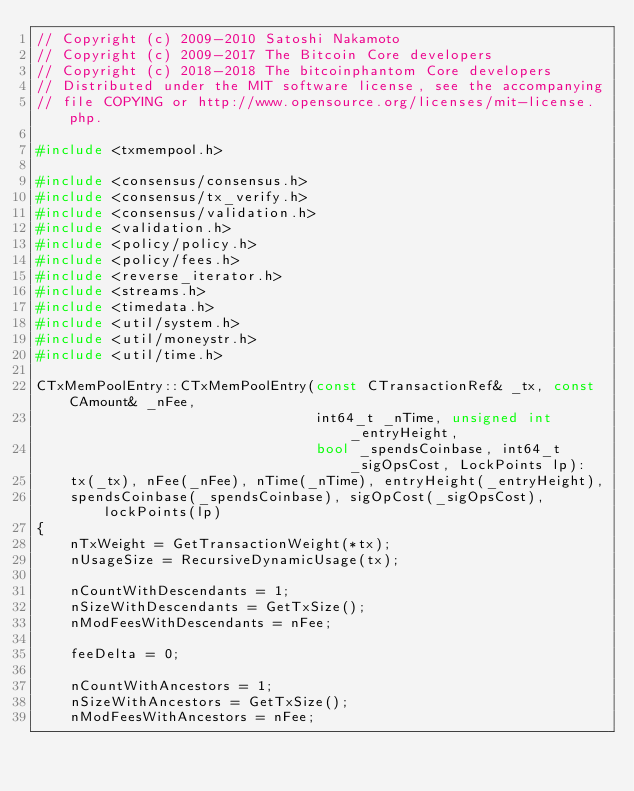<code> <loc_0><loc_0><loc_500><loc_500><_C++_>// Copyright (c) 2009-2010 Satoshi Nakamoto
// Copyright (c) 2009-2017 The Bitcoin Core developers
// Copyright (c) 2018-2018 The bitcoinphantom Core developers
// Distributed under the MIT software license, see the accompanying
// file COPYING or http://www.opensource.org/licenses/mit-license.php.

#include <txmempool.h>

#include <consensus/consensus.h>
#include <consensus/tx_verify.h>
#include <consensus/validation.h>
#include <validation.h>
#include <policy/policy.h>
#include <policy/fees.h>
#include <reverse_iterator.h>
#include <streams.h>
#include <timedata.h>
#include <util/system.h>
#include <util/moneystr.h>
#include <util/time.h>

CTxMemPoolEntry::CTxMemPoolEntry(const CTransactionRef& _tx, const CAmount& _nFee,
                                 int64_t _nTime, unsigned int _entryHeight,
                                 bool _spendsCoinbase, int64_t _sigOpsCost, LockPoints lp):
    tx(_tx), nFee(_nFee), nTime(_nTime), entryHeight(_entryHeight),
    spendsCoinbase(_spendsCoinbase), sigOpCost(_sigOpsCost), lockPoints(lp)
{
    nTxWeight = GetTransactionWeight(*tx);
    nUsageSize = RecursiveDynamicUsage(tx);

    nCountWithDescendants = 1;
    nSizeWithDescendants = GetTxSize();
    nModFeesWithDescendants = nFee;

    feeDelta = 0;

    nCountWithAncestors = 1;
    nSizeWithAncestors = GetTxSize();
    nModFeesWithAncestors = nFee;</code> 